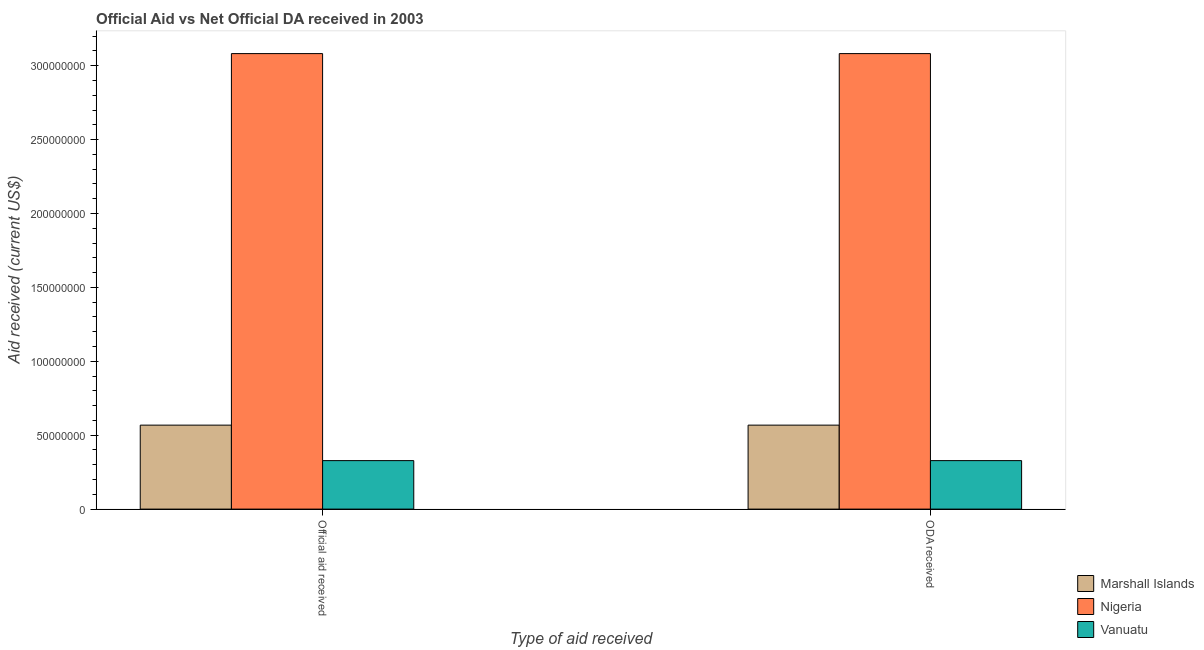How many different coloured bars are there?
Your response must be concise. 3. How many groups of bars are there?
Offer a terse response. 2. Are the number of bars per tick equal to the number of legend labels?
Your answer should be very brief. Yes. How many bars are there on the 1st tick from the right?
Give a very brief answer. 3. What is the label of the 1st group of bars from the left?
Give a very brief answer. Official aid received. What is the official aid received in Vanuatu?
Offer a terse response. 3.28e+07. Across all countries, what is the maximum official aid received?
Ensure brevity in your answer.  3.08e+08. Across all countries, what is the minimum official aid received?
Make the answer very short. 3.28e+07. In which country was the official aid received maximum?
Offer a terse response. Nigeria. In which country was the official aid received minimum?
Offer a terse response. Vanuatu. What is the total official aid received in the graph?
Keep it short and to the point. 3.98e+08. What is the difference between the oda received in Vanuatu and that in Nigeria?
Your response must be concise. -2.75e+08. What is the difference between the official aid received in Marshall Islands and the oda received in Vanuatu?
Provide a succinct answer. 2.40e+07. What is the average official aid received per country?
Provide a short and direct response. 1.33e+08. What is the difference between the official aid received and oda received in Nigeria?
Your answer should be very brief. 0. In how many countries, is the oda received greater than 120000000 US$?
Provide a short and direct response. 1. What is the ratio of the official aid received in Marshall Islands to that in Nigeria?
Give a very brief answer. 0.18. What does the 1st bar from the left in ODA received represents?
Provide a succinct answer. Marshall Islands. What does the 1st bar from the right in ODA received represents?
Your response must be concise. Vanuatu. What is the difference between two consecutive major ticks on the Y-axis?
Provide a succinct answer. 5.00e+07. Are the values on the major ticks of Y-axis written in scientific E-notation?
Your response must be concise. No. Does the graph contain any zero values?
Keep it short and to the point. No. Does the graph contain grids?
Make the answer very short. No. Where does the legend appear in the graph?
Offer a very short reply. Bottom right. How are the legend labels stacked?
Make the answer very short. Vertical. What is the title of the graph?
Provide a succinct answer. Official Aid vs Net Official DA received in 2003 . Does "Seychelles" appear as one of the legend labels in the graph?
Your answer should be compact. No. What is the label or title of the X-axis?
Offer a terse response. Type of aid received. What is the label or title of the Y-axis?
Make the answer very short. Aid received (current US$). What is the Aid received (current US$) in Marshall Islands in Official aid received?
Provide a short and direct response. 5.68e+07. What is the Aid received (current US$) in Nigeria in Official aid received?
Your answer should be compact. 3.08e+08. What is the Aid received (current US$) in Vanuatu in Official aid received?
Your answer should be very brief. 3.28e+07. What is the Aid received (current US$) in Marshall Islands in ODA received?
Give a very brief answer. 5.68e+07. What is the Aid received (current US$) in Nigeria in ODA received?
Make the answer very short. 3.08e+08. What is the Aid received (current US$) of Vanuatu in ODA received?
Your answer should be very brief. 3.28e+07. Across all Type of aid received, what is the maximum Aid received (current US$) of Marshall Islands?
Offer a terse response. 5.68e+07. Across all Type of aid received, what is the maximum Aid received (current US$) of Nigeria?
Ensure brevity in your answer.  3.08e+08. Across all Type of aid received, what is the maximum Aid received (current US$) in Vanuatu?
Ensure brevity in your answer.  3.28e+07. Across all Type of aid received, what is the minimum Aid received (current US$) in Marshall Islands?
Your answer should be compact. 5.68e+07. Across all Type of aid received, what is the minimum Aid received (current US$) of Nigeria?
Your answer should be compact. 3.08e+08. Across all Type of aid received, what is the minimum Aid received (current US$) in Vanuatu?
Your response must be concise. 3.28e+07. What is the total Aid received (current US$) in Marshall Islands in the graph?
Give a very brief answer. 1.14e+08. What is the total Aid received (current US$) in Nigeria in the graph?
Your answer should be very brief. 6.16e+08. What is the total Aid received (current US$) in Vanuatu in the graph?
Your answer should be compact. 6.56e+07. What is the difference between the Aid received (current US$) in Marshall Islands in Official aid received and that in ODA received?
Keep it short and to the point. 0. What is the difference between the Aid received (current US$) in Nigeria in Official aid received and that in ODA received?
Provide a short and direct response. 0. What is the difference between the Aid received (current US$) of Vanuatu in Official aid received and that in ODA received?
Provide a succinct answer. 0. What is the difference between the Aid received (current US$) of Marshall Islands in Official aid received and the Aid received (current US$) of Nigeria in ODA received?
Keep it short and to the point. -2.51e+08. What is the difference between the Aid received (current US$) of Marshall Islands in Official aid received and the Aid received (current US$) of Vanuatu in ODA received?
Keep it short and to the point. 2.40e+07. What is the difference between the Aid received (current US$) in Nigeria in Official aid received and the Aid received (current US$) in Vanuatu in ODA received?
Offer a very short reply. 2.75e+08. What is the average Aid received (current US$) of Marshall Islands per Type of aid received?
Your answer should be compact. 5.68e+07. What is the average Aid received (current US$) of Nigeria per Type of aid received?
Ensure brevity in your answer.  3.08e+08. What is the average Aid received (current US$) of Vanuatu per Type of aid received?
Make the answer very short. 3.28e+07. What is the difference between the Aid received (current US$) in Marshall Islands and Aid received (current US$) in Nigeria in Official aid received?
Make the answer very short. -2.51e+08. What is the difference between the Aid received (current US$) of Marshall Islands and Aid received (current US$) of Vanuatu in Official aid received?
Give a very brief answer. 2.40e+07. What is the difference between the Aid received (current US$) of Nigeria and Aid received (current US$) of Vanuatu in Official aid received?
Give a very brief answer. 2.75e+08. What is the difference between the Aid received (current US$) of Marshall Islands and Aid received (current US$) of Nigeria in ODA received?
Offer a terse response. -2.51e+08. What is the difference between the Aid received (current US$) in Marshall Islands and Aid received (current US$) in Vanuatu in ODA received?
Offer a very short reply. 2.40e+07. What is the difference between the Aid received (current US$) of Nigeria and Aid received (current US$) of Vanuatu in ODA received?
Provide a short and direct response. 2.75e+08. What is the ratio of the Aid received (current US$) in Marshall Islands in Official aid received to that in ODA received?
Provide a succinct answer. 1. What is the ratio of the Aid received (current US$) in Nigeria in Official aid received to that in ODA received?
Keep it short and to the point. 1. What is the ratio of the Aid received (current US$) in Vanuatu in Official aid received to that in ODA received?
Make the answer very short. 1. What is the difference between the highest and the second highest Aid received (current US$) of Nigeria?
Give a very brief answer. 0. What is the difference between the highest and the second highest Aid received (current US$) in Vanuatu?
Provide a short and direct response. 0. What is the difference between the highest and the lowest Aid received (current US$) of Vanuatu?
Keep it short and to the point. 0. 